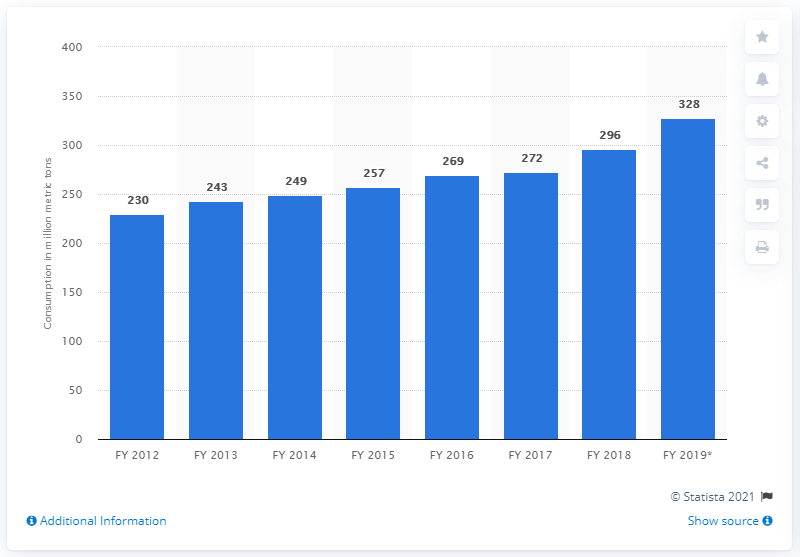Draw attention to some important aspects in this diagram. In 2018, the consumption of cement in India was 272 million metric tons. 